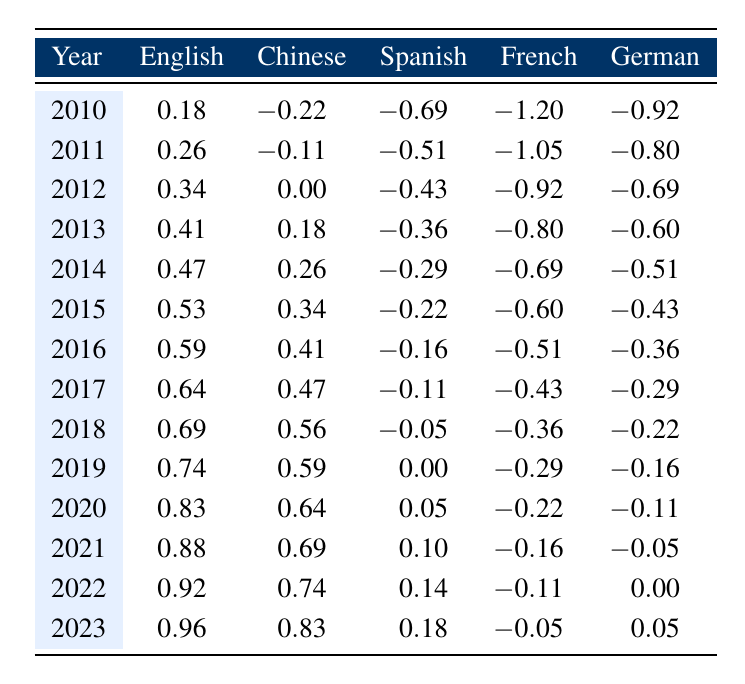What was the English book publication value in 2020? Looking at the row for the year 2020, the table shows the English book publication value as 2.3.
Answer: 2.3 What is the publication value of Spanish books in 2015? The table lists the Spanish book publication value for the year 2015 as 0.8.
Answer: 0.8 Which language had the highest publication value in 2023? Referring to the 2023 row, English has the highest publication value at 2.6 compared to other languages.
Answer: English Is the Chinese book publication value higher than the German value in 2018? In 2018, the Chinese book publication value is 1.75 while the German value is 0.8. Since 1.75 is greater than 0.8, the statement is true.
Answer: Yes What is the average publication value of French books from 2010 to 2023? By summing the French values from 2010 to 2023, we have: (-1.20 - 1.05 - 0.92 - 0.80 - 0.69 - 0.60 - 0.51 - 0.43 - 0.36 - 0.29 - 0.22 - 0.16 - 0.11 - 0.05) = -7.66. Dividing by the 14 years gives an average of -0.55.
Answer: -0.55 How much did the publication value of German books increase from 2010 to 2023? The value in 2010 is -0.92 and in 2023 it is 0.05. To find the increase, calculate: 0.05 - (-0.92) = 0.05 + 0.92 = 0.97.
Answer: 0.97 